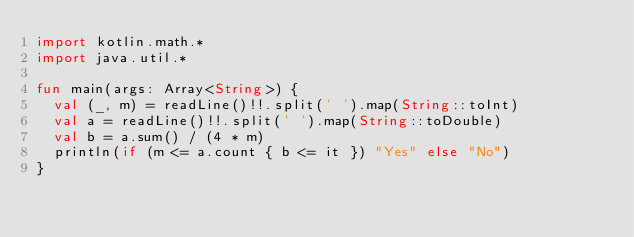Convert code to text. <code><loc_0><loc_0><loc_500><loc_500><_Kotlin_>import kotlin.math.*
import java.util.*

fun main(args: Array<String>) {
  val (_, m) = readLine()!!.split(' ').map(String::toInt)
  val a = readLine()!!.split(' ').map(String::toDouble)
  val b = a.sum() / (4 * m)
  println(if (m <= a.count { b <= it }) "Yes" else "No")
}
</code> 